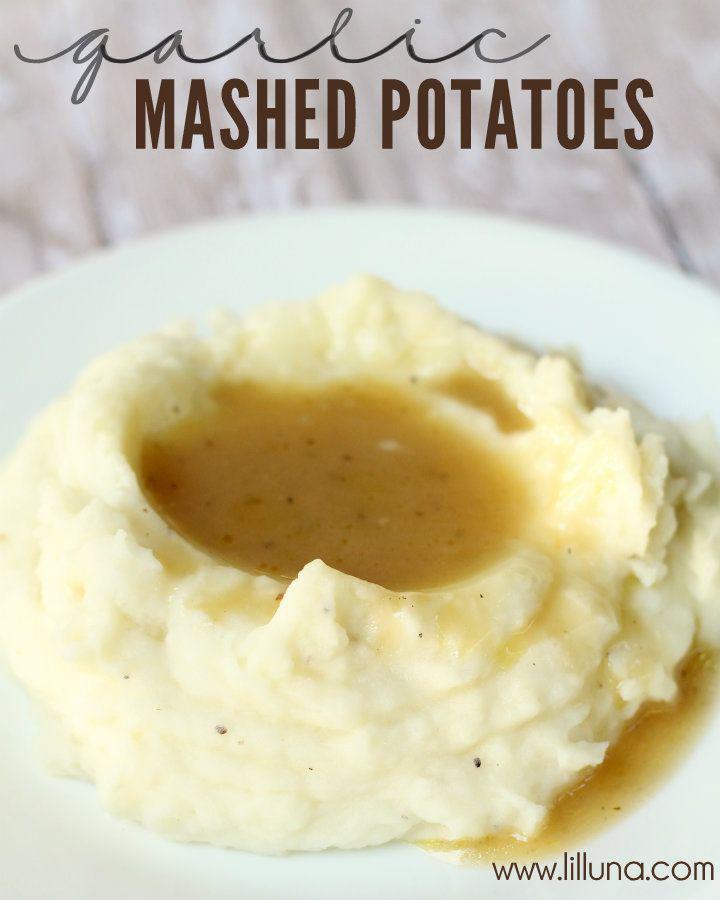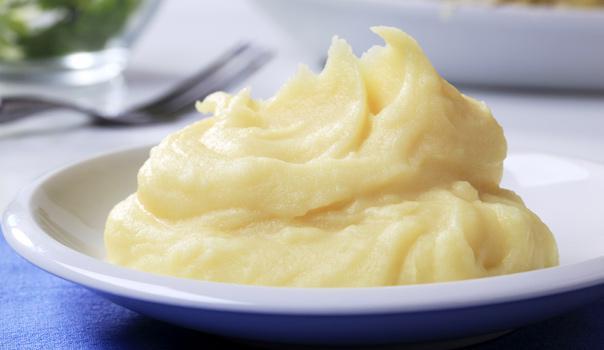The first image is the image on the left, the second image is the image on the right. Examine the images to the left and right. Is the description "One of the dishes of potatoes has a utensil stuck into the food." accurate? Answer yes or no. No. The first image is the image on the left, the second image is the image on the right. Analyze the images presented: Is the assertion "There is a white plate of mashed potatoes and gravy in the image on the left." valid? Answer yes or no. Yes. 